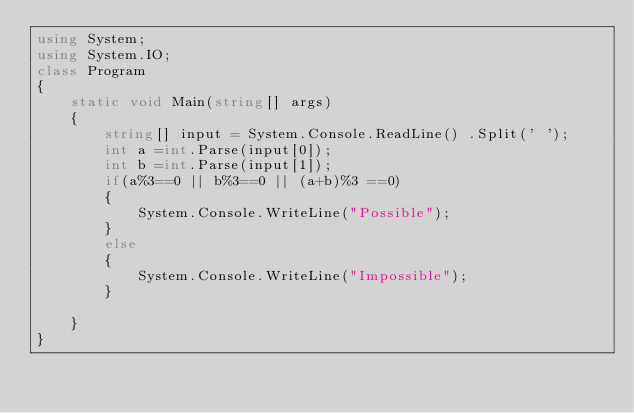Convert code to text. <code><loc_0><loc_0><loc_500><loc_500><_C#_>using System;
using System.IO;
class Program
{
    static void Main(string[] args)
    {
        string[] input = System.Console.ReadLine() .Split(' ');
        int a =int.Parse(input[0]);
        int b =int.Parse(input[1]);
        if(a%3==0 || b%3==0 || (a+b)%3 ==0)
        {
            System.Console.WriteLine("Possible");
        }
        else
        {
            System.Console.WriteLine("Impossible");
        }
        
    }
}</code> 